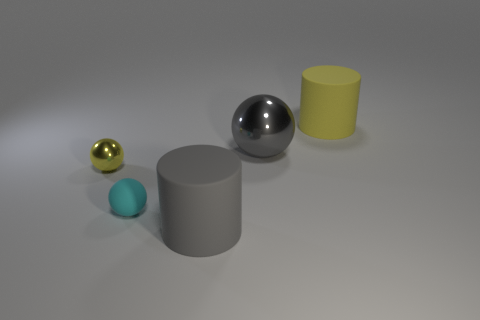What is the color of the matte object that is both right of the tiny matte sphere and in front of the yellow rubber cylinder?
Provide a short and direct response. Gray. There is a yellow thing that is the same size as the gray ball; what shape is it?
Ensure brevity in your answer.  Cylinder. Are there any large matte cylinders that have the same color as the tiny rubber sphere?
Ensure brevity in your answer.  No. Are there an equal number of tiny yellow spheres that are behind the yellow rubber thing and small blocks?
Offer a very short reply. Yes. Is the color of the big metal thing the same as the tiny metal ball?
Provide a succinct answer. No. What is the size of the rubber thing that is both left of the large yellow matte object and to the right of the small cyan ball?
Ensure brevity in your answer.  Large. What color is the big cylinder that is the same material as the big yellow thing?
Your answer should be compact. Gray. How many large gray things are made of the same material as the yellow sphere?
Your answer should be compact. 1. Are there an equal number of yellow cylinders that are behind the large yellow rubber object and large gray matte cylinders behind the big metallic object?
Your answer should be very brief. Yes. There is a gray shiny object; does it have the same shape as the big rubber thing in front of the yellow metal object?
Your answer should be compact. No. 